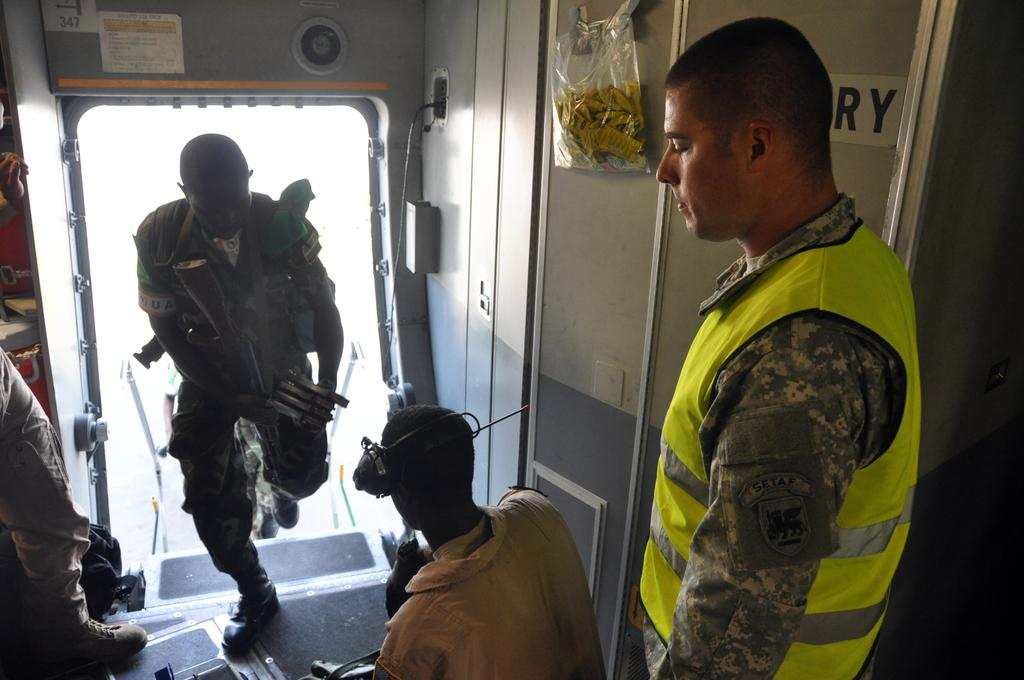What can be seen in the foreground of the picture? In the foreground of the picture, there are people, a wall, a door, and a staircase. What are the people in the picture doing? The people in the picture are carrying objects. What architectural feature is present in the foreground of the picture? There is a staircase in the foreground of the picture. What type of market can be seen in the background of the image? There is no market present in the image; it only shows people, a wall, a door, and a staircase in the foreground. How many cars are parked near the people in the image? There are no cars visible in the image. 